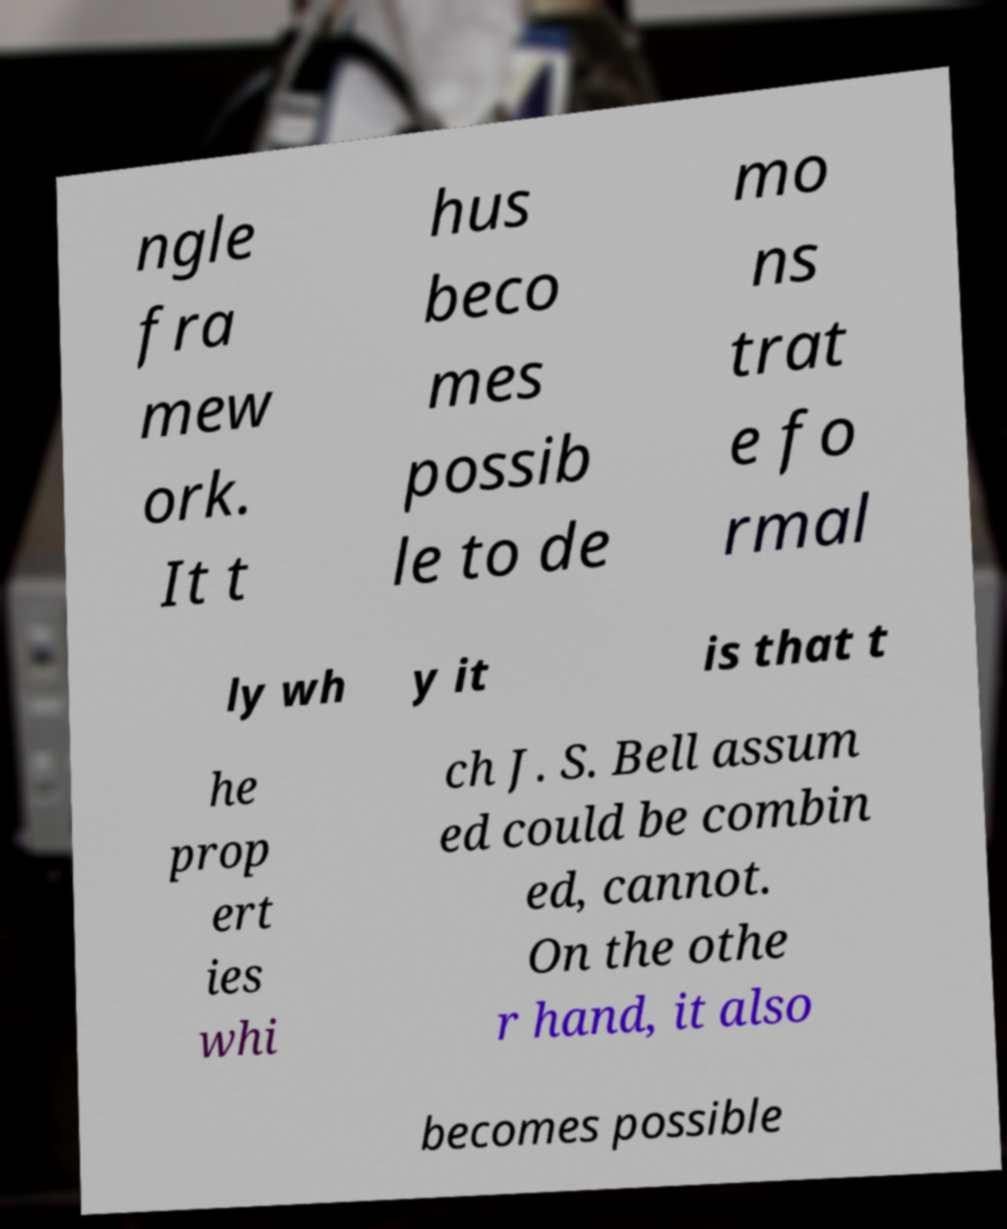Could you assist in decoding the text presented in this image and type it out clearly? ngle fra mew ork. It t hus beco mes possib le to de mo ns trat e fo rmal ly wh y it is that t he prop ert ies whi ch J. S. Bell assum ed could be combin ed, cannot. On the othe r hand, it also becomes possible 